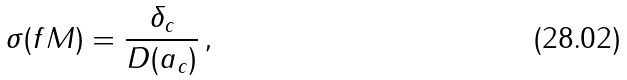Convert formula to latex. <formula><loc_0><loc_0><loc_500><loc_500>\sigma ( f M ) = \frac { \delta _ { c } } { D ( a _ { c } ) } \, ,</formula> 